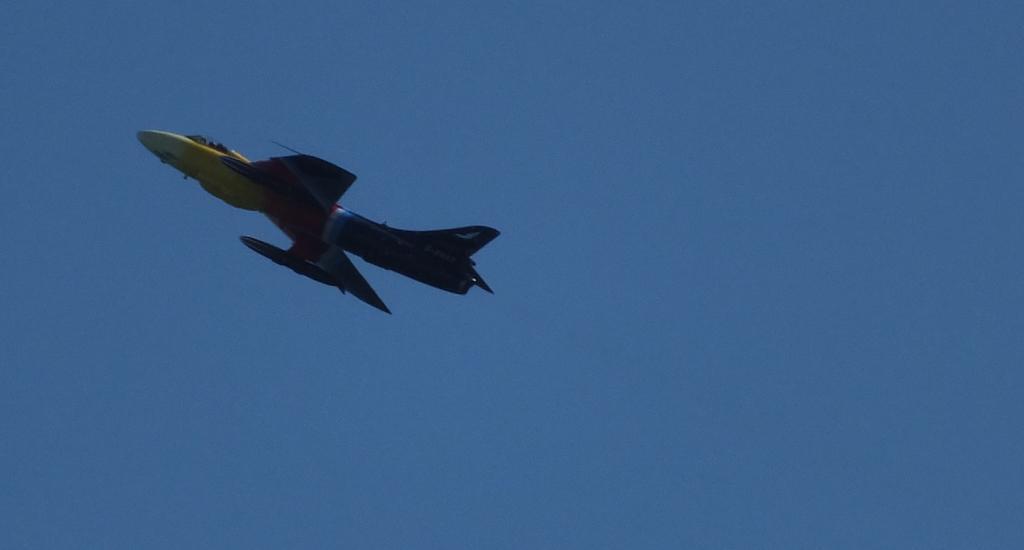Can you describe this image briefly? In this image we can see an aircraft is flying in the air. In the background, we can see the blue color sky. 